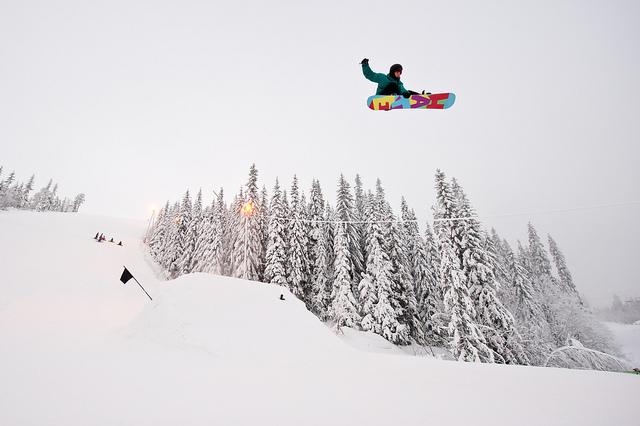How high is the snowboarder?
Quick response, please. 20 feet. What color is the snow?
Short answer required. White. What color is the flag?
Keep it brief. Black. 